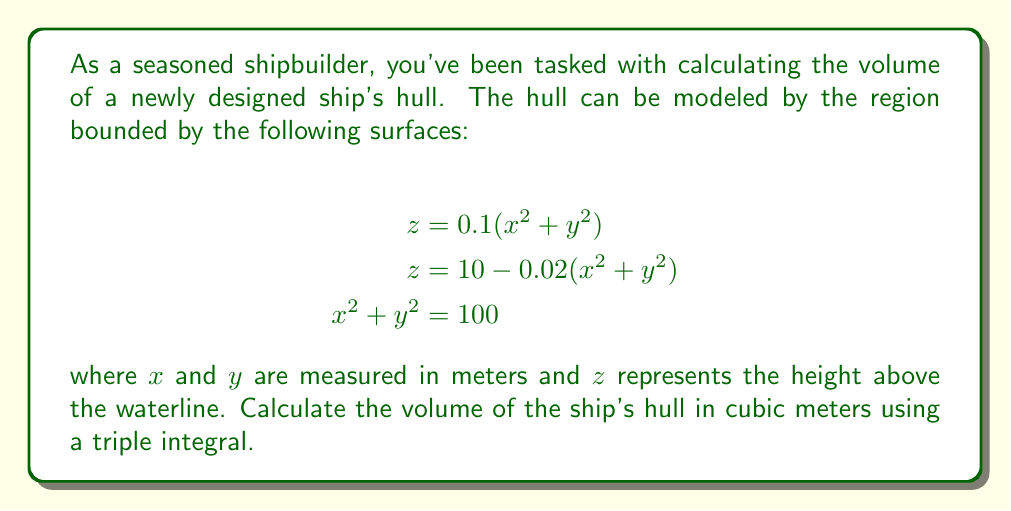Teach me how to tackle this problem. To calculate the volume of the ship's hull, we need to set up and evaluate a triple integral. Let's approach this step-by-step:

1) First, we need to determine the limits of integration. From the given equations:
   - The hull is circular in the xy-plane with radius 10 m (from $x^2 + y^2 = 100$)
   - The bottom surface is $z = 0.1(x^2 + y^2)$
   - The top surface is $z = 10 - 0.02(x^2 + y^2)$

2) Due to the circular symmetry, it's best to use cylindrical coordinates:
   $x = r\cos\theta$, $y = r\sin\theta$, $z = z$

3) The volume integral in cylindrical coordinates is:
   $$V = \int_0^{2\pi} \int_0^{10} \int_{0.1r^2}^{10-0.02r^2} r \, dz \, dr \, d\theta$$

4) Let's evaluate the innermost integral first:
   $$\int_{0.1r^2}^{10-0.02r^2} dz = [z]_{0.1r^2}^{10-0.02r^2} = (10-0.02r^2) - 0.1r^2 = 10 - 0.12r^2$$

5) Now our double integral is:
   $$V = \int_0^{2\pi} \int_0^{10} (10 - 0.12r^2)r \, dr \, d\theta$$

6) Evaluate the $r$ integral:
   $$\int_0^{10} (10r - 0.12r^3) \, dr = [5r^2 - 0.03r^4]_0^{10} = 500 - 300 = 200$$

7) Finally, integrate with respect to $\theta$:
   $$V = \int_0^{2\pi} 200 \, d\theta = 200 [{\theta}]_0^{2\pi} = 400\pi$$

Therefore, the volume of the ship's hull is $400\pi$ cubic meters.
Answer: $400\pi$ cubic meters 